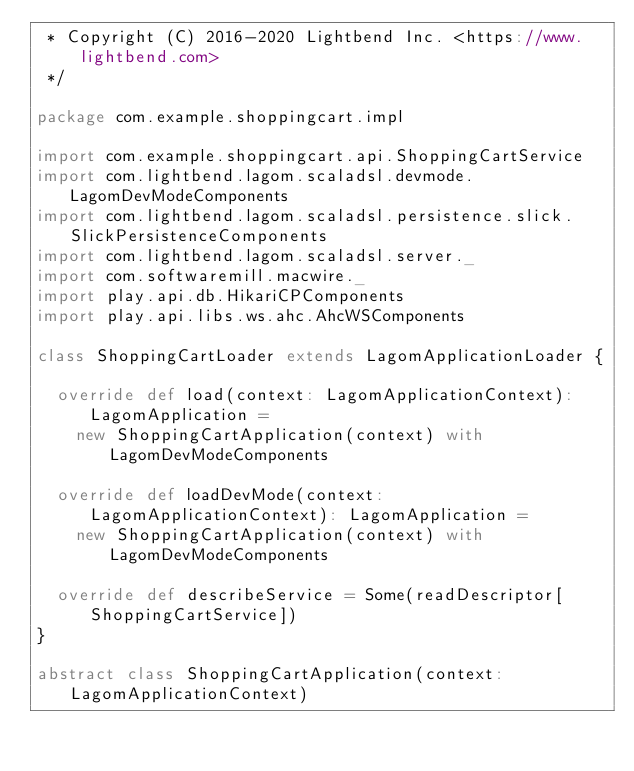Convert code to text. <code><loc_0><loc_0><loc_500><loc_500><_Scala_> * Copyright (C) 2016-2020 Lightbend Inc. <https://www.lightbend.com>
 */

package com.example.shoppingcart.impl

import com.example.shoppingcart.api.ShoppingCartService
import com.lightbend.lagom.scaladsl.devmode.LagomDevModeComponents
import com.lightbend.lagom.scaladsl.persistence.slick.SlickPersistenceComponents
import com.lightbend.lagom.scaladsl.server._
import com.softwaremill.macwire._
import play.api.db.HikariCPComponents
import play.api.libs.ws.ahc.AhcWSComponents

class ShoppingCartLoader extends LagomApplicationLoader {

  override def load(context: LagomApplicationContext): LagomApplication =
    new ShoppingCartApplication(context) with LagomDevModeComponents

  override def loadDevMode(context: LagomApplicationContext): LagomApplication =
    new ShoppingCartApplication(context) with LagomDevModeComponents

  override def describeService = Some(readDescriptor[ShoppingCartService])
}

abstract class ShoppingCartApplication(context: LagomApplicationContext)</code> 